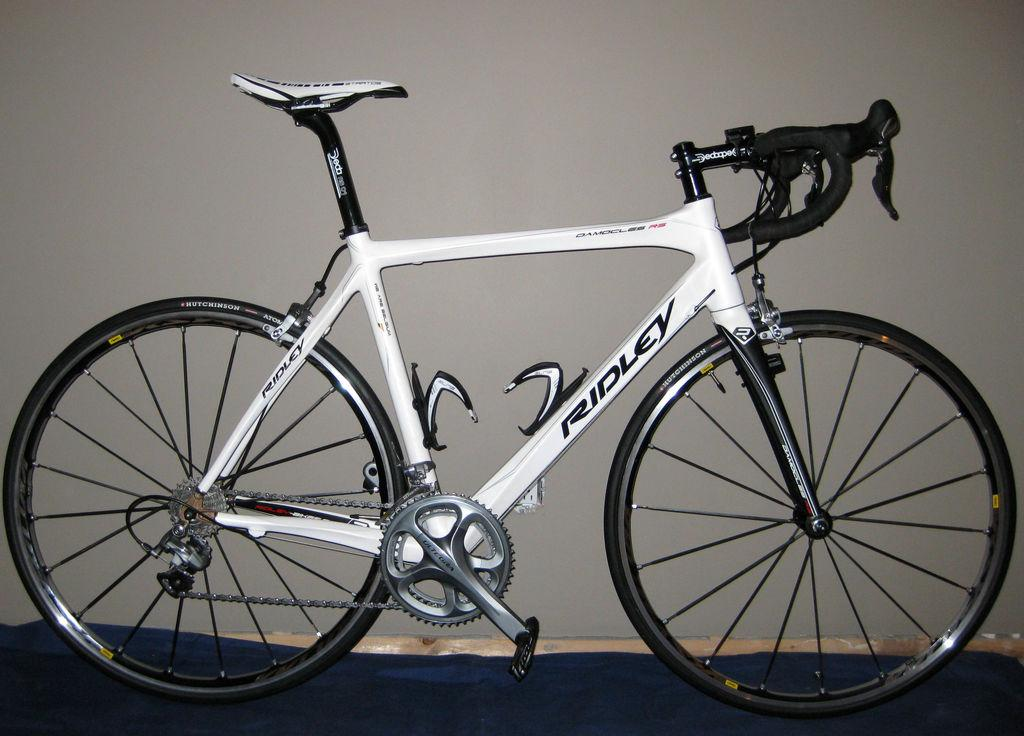What is the main object in the image? There is a bicycle in the image. How is the bicycle positioned in the image? The bicycle is placed on the ground. What can be seen in the background of the image? There is a white color board in the background of the image. How many people are shaking hands in the image? There are no people present in the image, so no one is shaking hands. What type of territory is depicted in the image? The image does not depict any territory; it features a bicycle placed on the ground and a white color board in the background. 